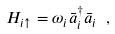Convert formula to latex. <formula><loc_0><loc_0><loc_500><loc_500>H _ { i \uparrow } = \omega _ { i } \bar { a } _ { i } ^ { \dagger } \bar { a } _ { i } \ ,</formula> 